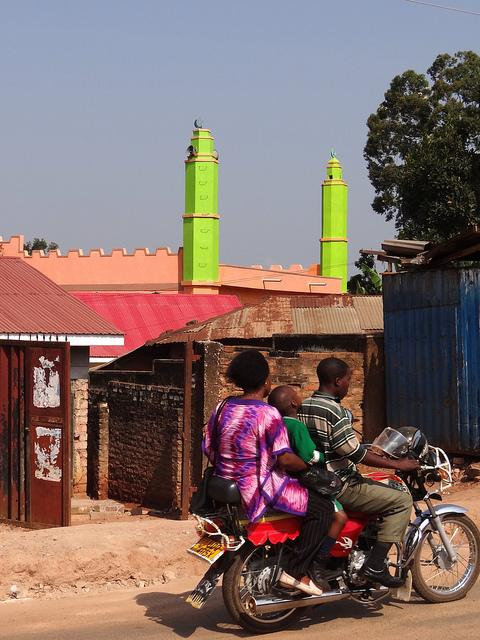Why are three people on the bike? Please explain your reasoning. cheap transportation. That is how many poorer country's citizens get around. 